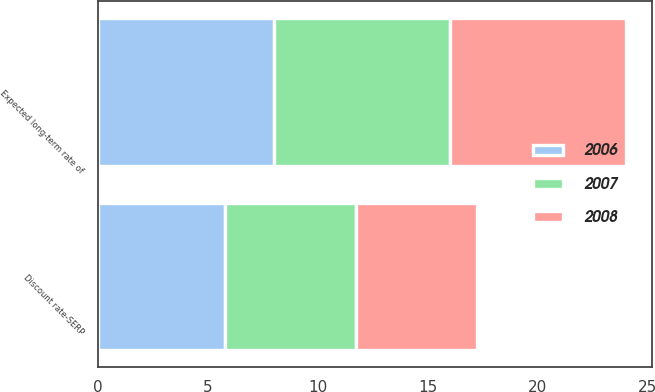Convert chart. <chart><loc_0><loc_0><loc_500><loc_500><stacked_bar_chart><ecel><fcel>Discount rate-SERP<fcel>Expected long-term rate of<nl><fcel>2007<fcel>6<fcel>8<nl><fcel>2008<fcel>5.5<fcel>8<nl><fcel>2006<fcel>5.75<fcel>8<nl></chart> 